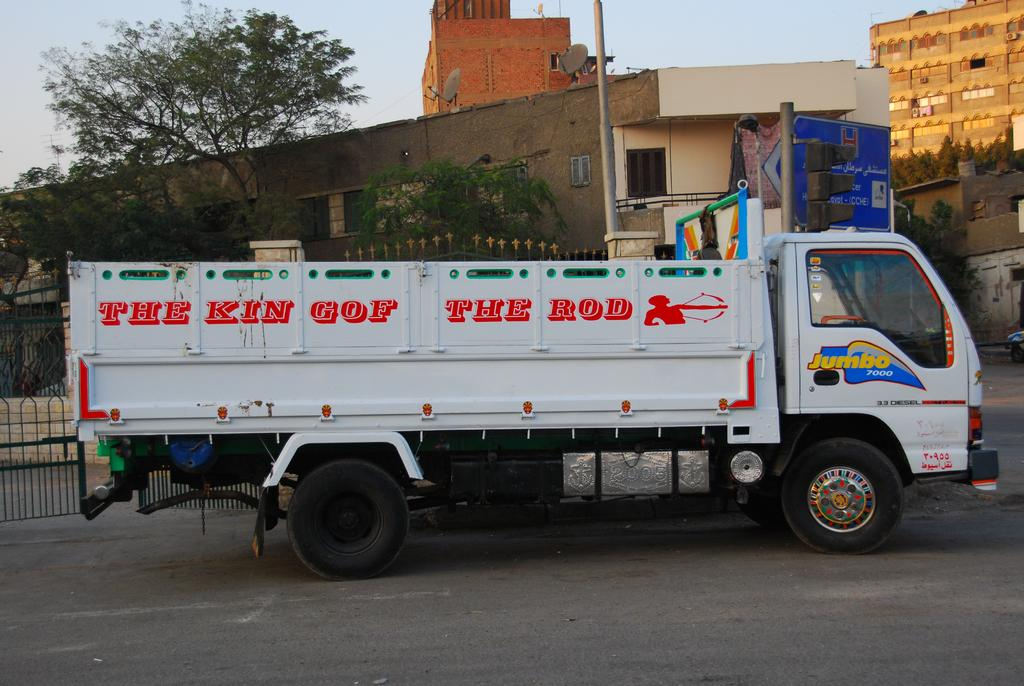<image>
Summarize the visual content of the image. A white truck that has red writing on the side that reads "The King of the Rod" 